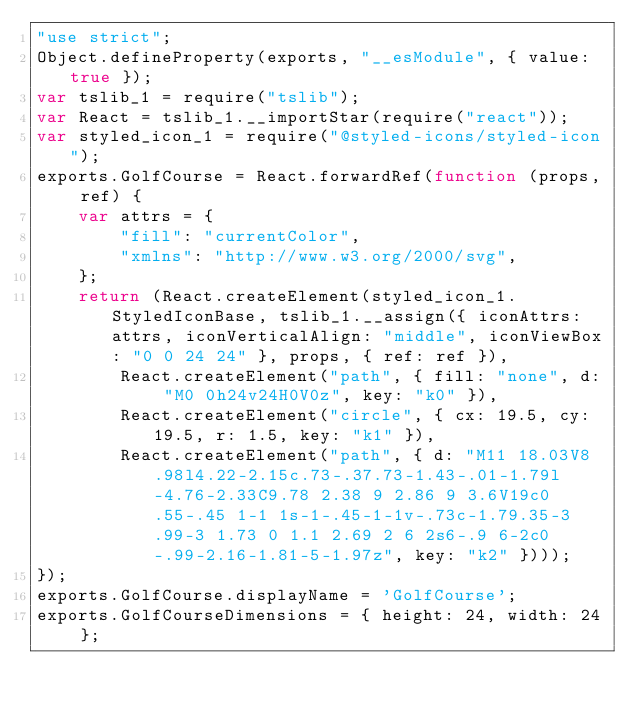Convert code to text. <code><loc_0><loc_0><loc_500><loc_500><_JavaScript_>"use strict";
Object.defineProperty(exports, "__esModule", { value: true });
var tslib_1 = require("tslib");
var React = tslib_1.__importStar(require("react"));
var styled_icon_1 = require("@styled-icons/styled-icon");
exports.GolfCourse = React.forwardRef(function (props, ref) {
    var attrs = {
        "fill": "currentColor",
        "xmlns": "http://www.w3.org/2000/svg",
    };
    return (React.createElement(styled_icon_1.StyledIconBase, tslib_1.__assign({ iconAttrs: attrs, iconVerticalAlign: "middle", iconViewBox: "0 0 24 24" }, props, { ref: ref }),
        React.createElement("path", { fill: "none", d: "M0 0h24v24H0V0z", key: "k0" }),
        React.createElement("circle", { cx: 19.5, cy: 19.5, r: 1.5, key: "k1" }),
        React.createElement("path", { d: "M11 18.03V8.98l4.22-2.15c.73-.37.73-1.43-.01-1.79l-4.76-2.33C9.78 2.38 9 2.86 9 3.6V19c0 .55-.45 1-1 1s-1-.45-1-1v-.73c-1.79.35-3 .99-3 1.73 0 1.1 2.69 2 6 2s6-.9 6-2c0-.99-2.16-1.81-5-1.97z", key: "k2" })));
});
exports.GolfCourse.displayName = 'GolfCourse';
exports.GolfCourseDimensions = { height: 24, width: 24 };
</code> 